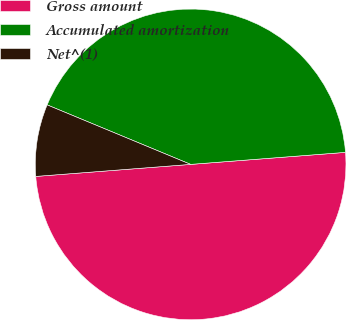Convert chart. <chart><loc_0><loc_0><loc_500><loc_500><pie_chart><fcel>Gross amount<fcel>Accumulated amortization<fcel>Net^(1)<nl><fcel>50.0%<fcel>42.51%<fcel>7.49%<nl></chart> 